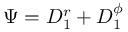Convert formula to latex. <formula><loc_0><loc_0><loc_500><loc_500>\Psi = D _ { 1 } ^ { r } + D _ { 1 } ^ { \phi }</formula> 